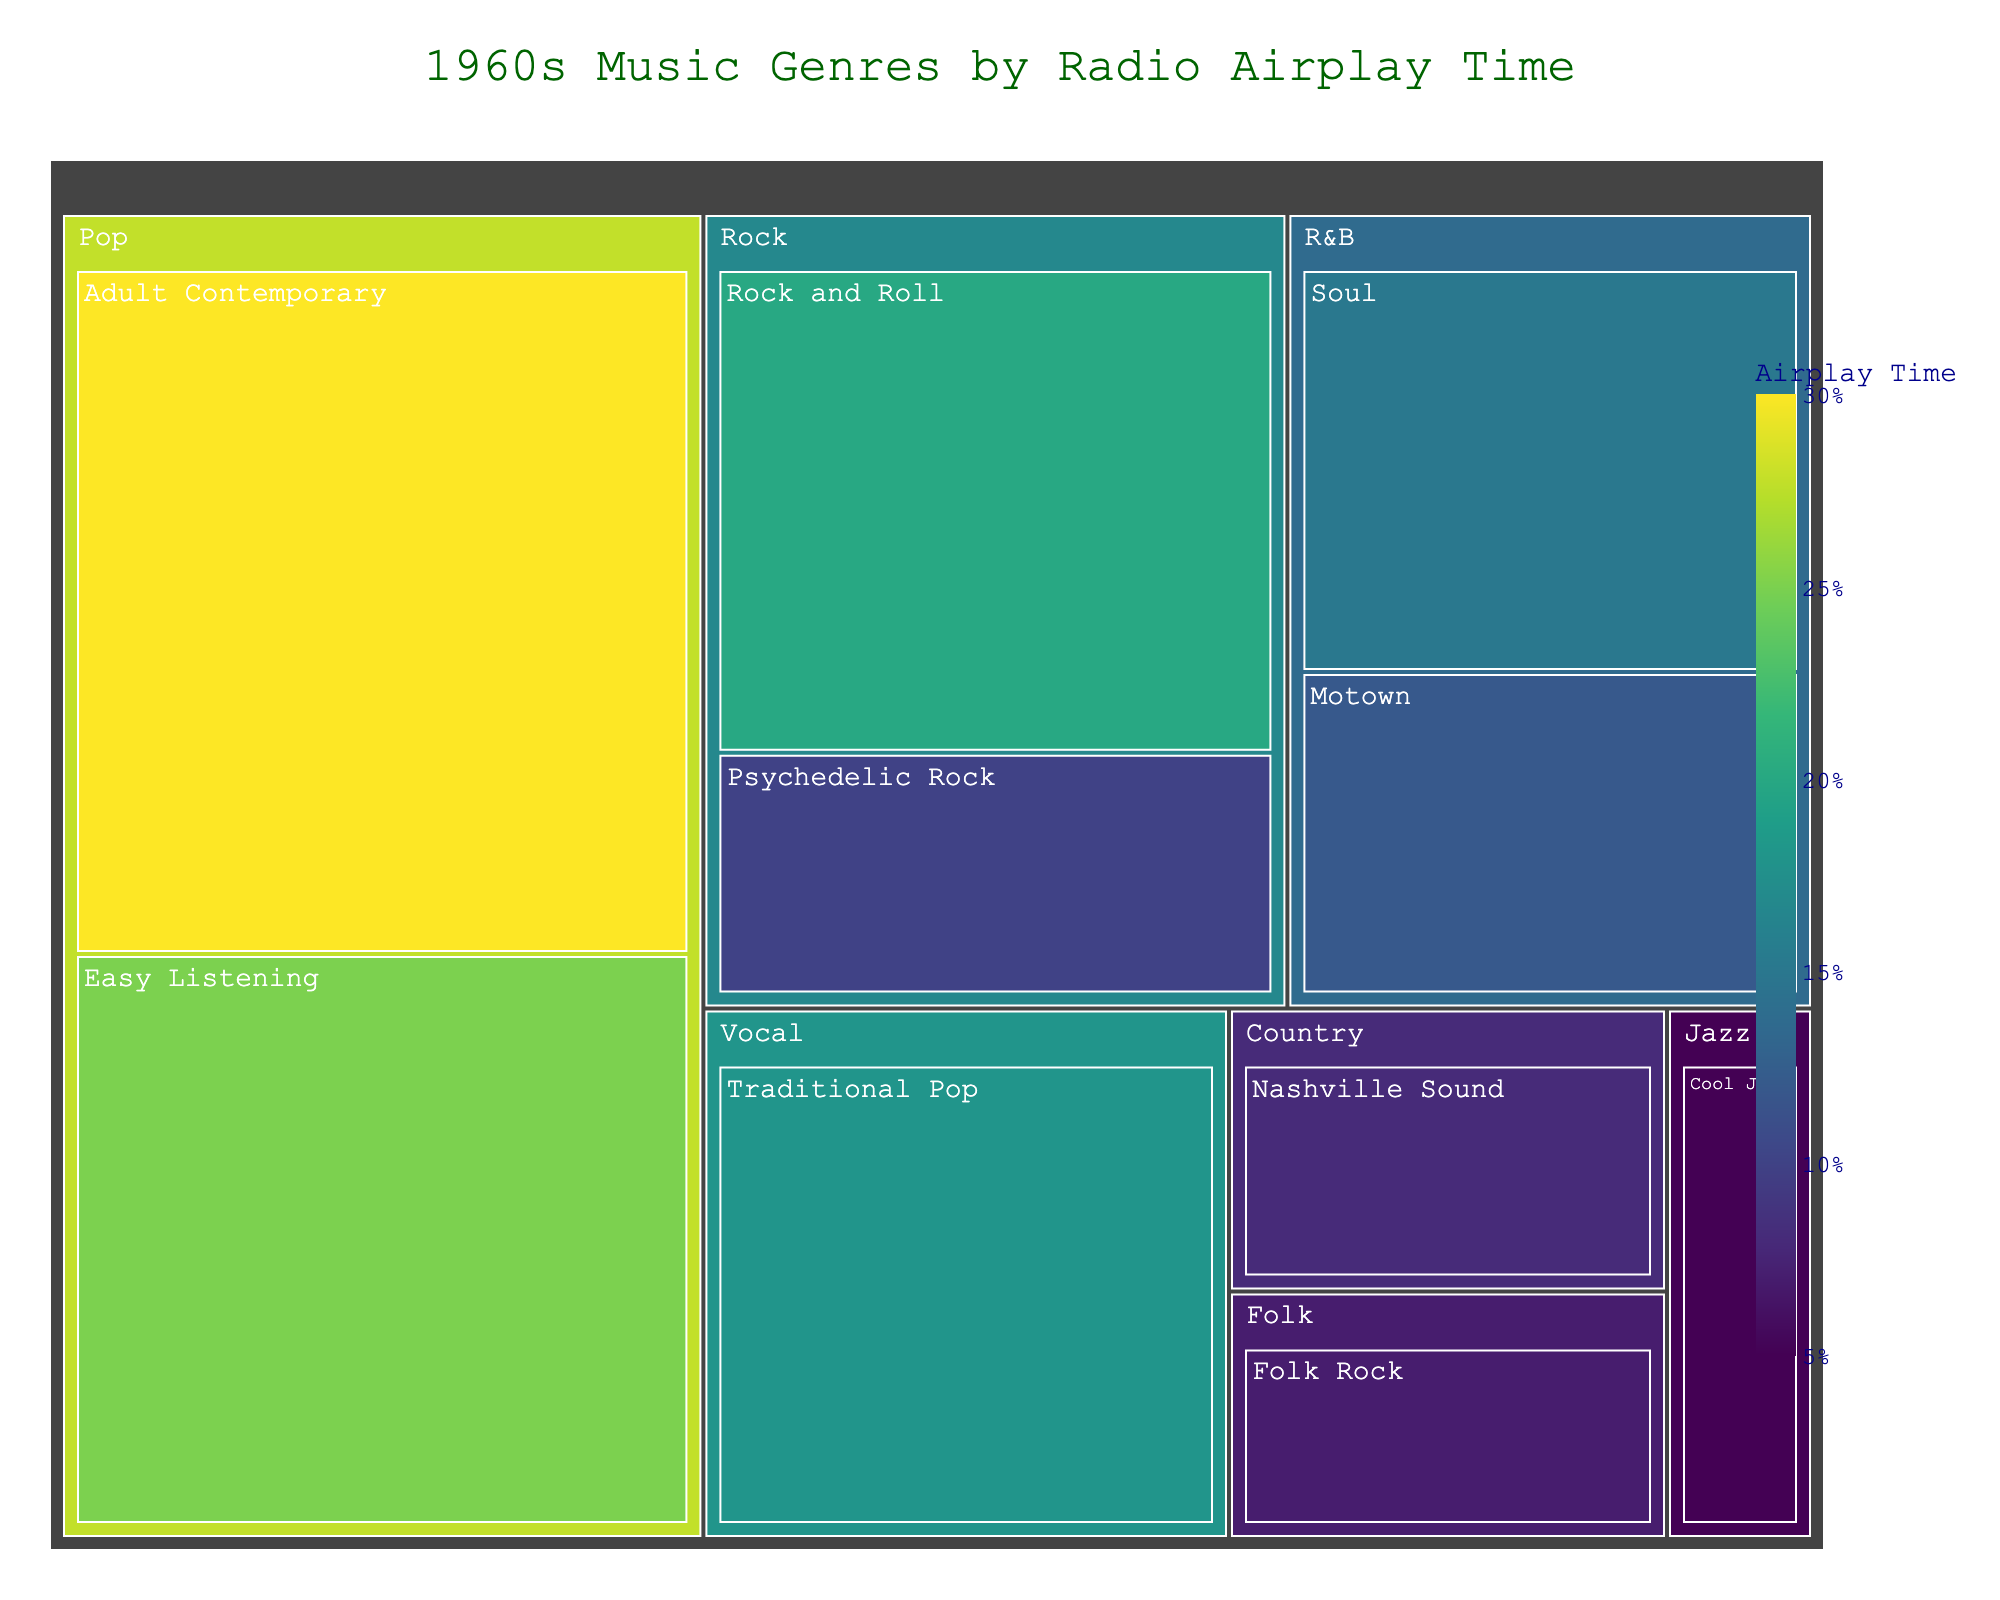What's the genre with the highest airplay time? According to the treemap, Pop genre has the largest area, indicating it occupies the highest airplay time.
Answer: Pop Which subgenre within the Pop genre has more airplay time? Within Pop, Adult Contemporary has more airplay time as it has a larger area compared to Easy Listening.
Answer: Adult Contemporary What is the total airplay time for R&B subgenres? Summing the airplay time for Soul (15) and Motown (12) gives a total airplay time of 27.
Answer: 27 Which genre occupies the smallest amount of airplay time? By examining the smallest areas on the treemap, Jazz with Cool Jazz having 5 airplay time appears to be the smallest.
Answer: Jazz Is Traditional Pop a subgenre of Rock? The treemap does not place Traditional Pop within the Rock category; it is under the Vocal genre.
Answer: No Compare the airplay time between Rock and Folk genres. Which one has more airplay? Summing the airplay time for Rock subgenres (Rock and Roll: 20, Psychedelic Rock: 10) gives 30, whereas Folk Rock's airplay time is 7. Thus, Rock has more airplay time.
Answer: Rock What is the combined airplay time for Pop and Vocal genres? Summing the airplay time for Pop (30 + 25) and Vocal (18) gives a combined airplay time of 73.
Answer: 73 If we combine the airplay time of all subgenres under Rock and R&B, which would have more—Rock or R&B? For Rock: Rock and Roll (20) + Psychedelic Rock (10) = 30. For R&B: Soul (15) + Motown (12) = 27. Thus, Rock has more airplay time.
Answer: Rock Which subgenre of Pop has less airplay time, and by how much compared to the other subgenre? Easy Listening has 25 airplay time, which is 5 less than Adult Contemporary's 30.
Answer: Easy Listening; 5 What is the total airplay time for all subgenres listed in the treemap? Summing the airplay times for all subgenres gives 30 (Pop-Adult Contemporary) + 25 (Pop-Easy Listening) + 20 (Rock-Rock and Roll) + 10 (Rock-Psychedelic Rock) + 15 (R&B-Soul) + 12 (R&B-Motown) + 8 (Country-Nashville Sound) + 5 (Jazz-Cool Jazz) + 7 (Folk-Folk Rock) + 18 (Vocal-Traditional Pop) = 150.
Answer: 150 